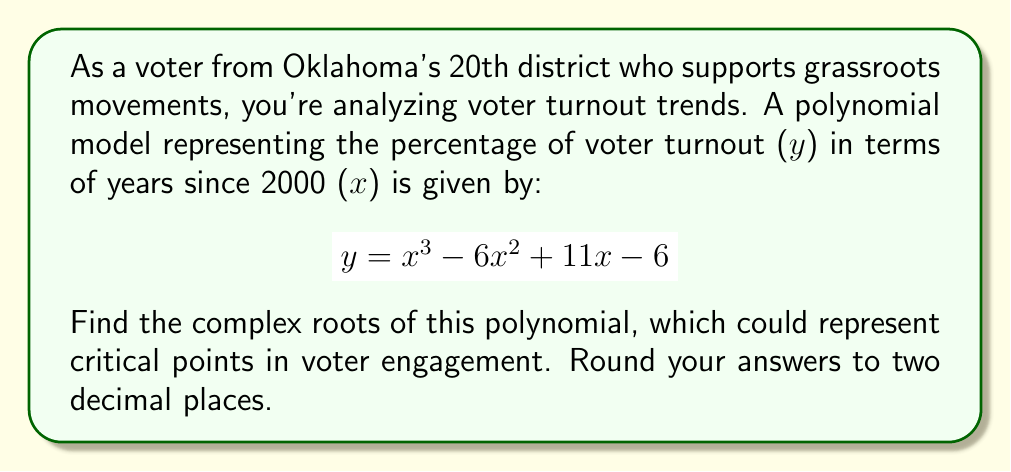Can you solve this math problem? To find the complex roots of the polynomial, we'll follow these steps:

1) First, let's recognize that this is a cubic equation in the form:
   $$ ax^3 + bx^2 + cx + d = 0 $$
   where $a=1$, $b=-6$, $c=11$, and $d=-6$

2) We can use the cubic formula, but it's complex. Instead, let's try to factor it first.

3) We can guess that one root might be a whole number. By testing, we find that $x=1$ is a root:
   $$ 1^3 - 6(1)^2 + 11(1) - 6 = 1 - 6 + 11 - 6 = 0 $$

4) So we can factor out $(x-1)$:
   $$ x^3 - 6x^2 + 11x - 6 = (x-1)(x^2 - 5x + 6) $$

5) Now we have a quadratic equation to solve: $x^2 - 5x + 6 = 0$

6) We can solve this using the quadratic formula: $x = \frac{-b \pm \sqrt{b^2 - 4ac}}{2a}$

   Where $a=1$, $b=-5$, and $c=6$

   $$ x = \frac{5 \pm \sqrt{25 - 24}}{2} = \frac{5 \pm 1}{2} $$

7) This gives us two more roots: $x = 3$ and $x = 2$

Therefore, the three roots are 1, 2, and 3. These are all real roots, but in complex number form, we express them as $1+0i$, $2+0i$, and $3+0i$.
Answer: The complex roots of the polynomial are: $1+0i$, $2+0i$, and $3+0i$. 